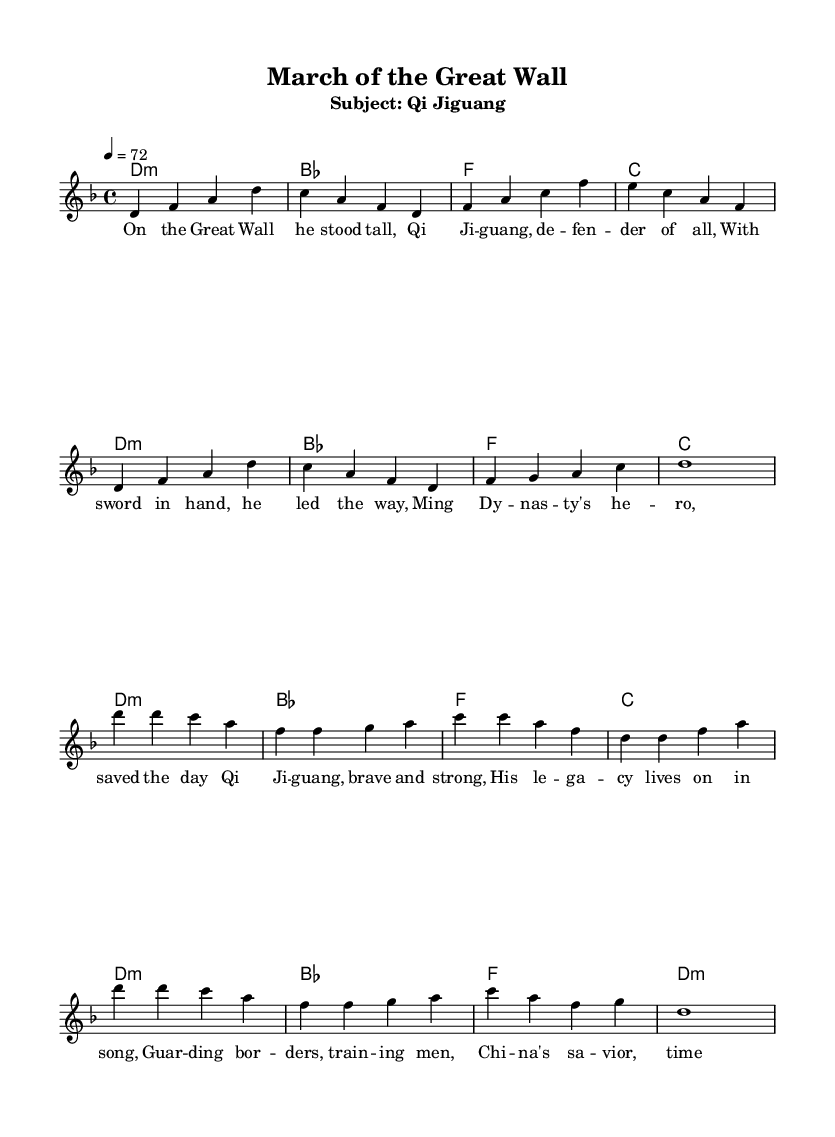What is the key signature of this music? The key signature displayed is D minor, which is indicated by the presence of one flat (B flat) in the key.
Answer: D minor What is the time signature of this music? The time signature shown at the beginning of the sheet music is 4/4, meaning there are four beats in each measure, and the quarter note receives one beat.
Answer: 4/4 What is the tempo marking for this piece? The tempo marking in the sheet music indicates a speed of 72 beats per minute, which is specified at the beginning.
Answer: 72 Who is the subject of this song? The subtitle of the music indicates that the song recounts the life of Qi Jiguang, a famous Chinese military leader.
Answer: Qi Jiguang How many verses are in this Reggae ballad? The sheet music includes one verse followed by a chorus, indicating there is one verse segment presented.
Answer: One What thematic element is central to this Reggae ballad? The lyrics highlight themes of bravery and defense, specifically focusing on Qi Jiguang’s contributions to guarding the borders and training men.
Answer: Bravery What is the notable instrumentation indicated in the sheet music? The sheet music contains a staff notation for a lead voice and chords, typical for Reggae music's accompaniment style.
Answer: Lead voice 